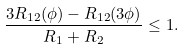<formula> <loc_0><loc_0><loc_500><loc_500>\frac { 3 R _ { 1 2 } ( \phi ) - R _ { 1 2 } ( 3 \phi ) } { R _ { 1 } + R _ { 2 } } \leq 1 .</formula> 